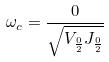Convert formula to latex. <formula><loc_0><loc_0><loc_500><loc_500>\omega _ { c } = \frac { 0 } { \sqrt { V _ { \frac { 0 } { 2 } } J _ { \frac { 0 } { 2 } } } }</formula> 